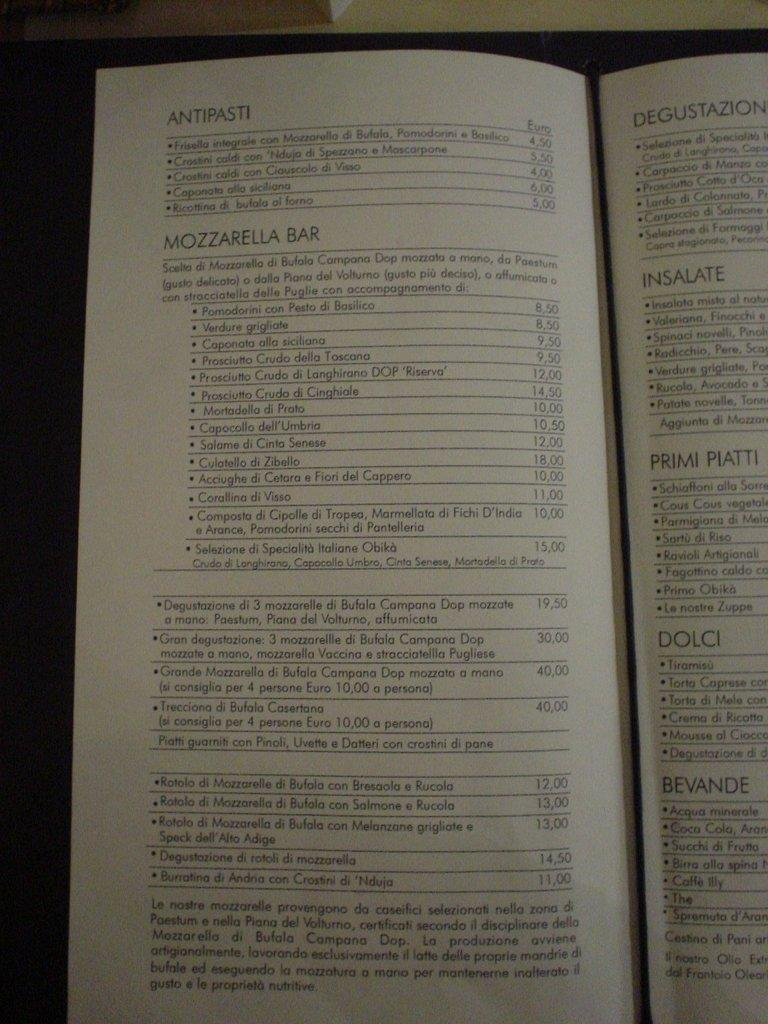<image>
Describe the image concisely. Antipasti showing the euros and bars that contain types of drinks 